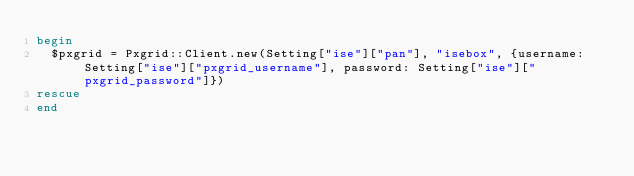Convert code to text. <code><loc_0><loc_0><loc_500><loc_500><_Ruby_>begin
  $pxgrid = Pxgrid::Client.new(Setting["ise"]["pan"], "isebox", {username: Setting["ise"]["pxgrid_username"], password: Setting["ise"]["pxgrid_password"]})
rescue
end
</code> 